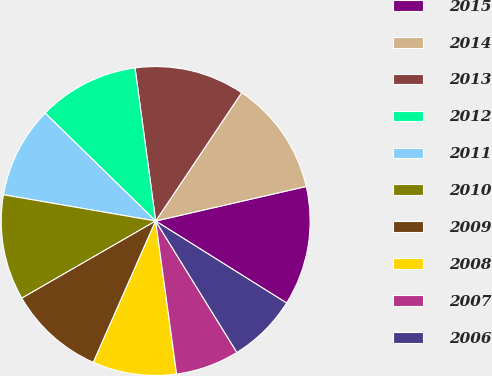Convert chart to OTSL. <chart><loc_0><loc_0><loc_500><loc_500><pie_chart><fcel>2015<fcel>2014<fcel>2013<fcel>2012<fcel>2011<fcel>2010<fcel>2009<fcel>2008<fcel>2007<fcel>2006<nl><fcel>12.5%<fcel>12.01%<fcel>11.53%<fcel>10.56%<fcel>9.59%<fcel>11.04%<fcel>10.07%<fcel>8.77%<fcel>6.65%<fcel>7.28%<nl></chart> 